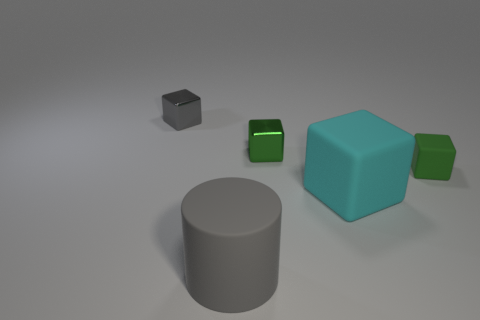Does the large gray object have the same material as the large cyan block that is in front of the small gray object?
Provide a succinct answer. Yes. There is a large object right of the big gray matte cylinder; what color is it?
Keep it short and to the point. Cyan. There is a small green thing right of the large block; are there any cubes in front of it?
Make the answer very short. Yes. Is the color of the shiny block right of the gray rubber cylinder the same as the small block that is on the right side of the cyan thing?
Offer a very short reply. Yes. There is a big cyan object; what number of gray rubber objects are in front of it?
Your answer should be very brief. 1. How many other large matte cylinders have the same color as the cylinder?
Keep it short and to the point. 0. Is the gray thing that is to the right of the small gray metal object made of the same material as the small gray object?
Offer a terse response. No. How many big brown things have the same material as the gray cylinder?
Your answer should be very brief. 0. Are there more tiny gray metallic blocks that are behind the small green metal cube than tiny blue metal balls?
Keep it short and to the point. Yes. There is another thing that is the same color as the small rubber object; what size is it?
Give a very brief answer. Small. 